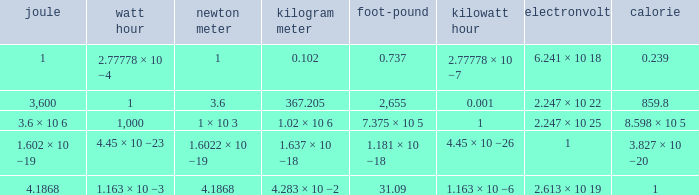How many calories is 1 watt hour? 859.8. 